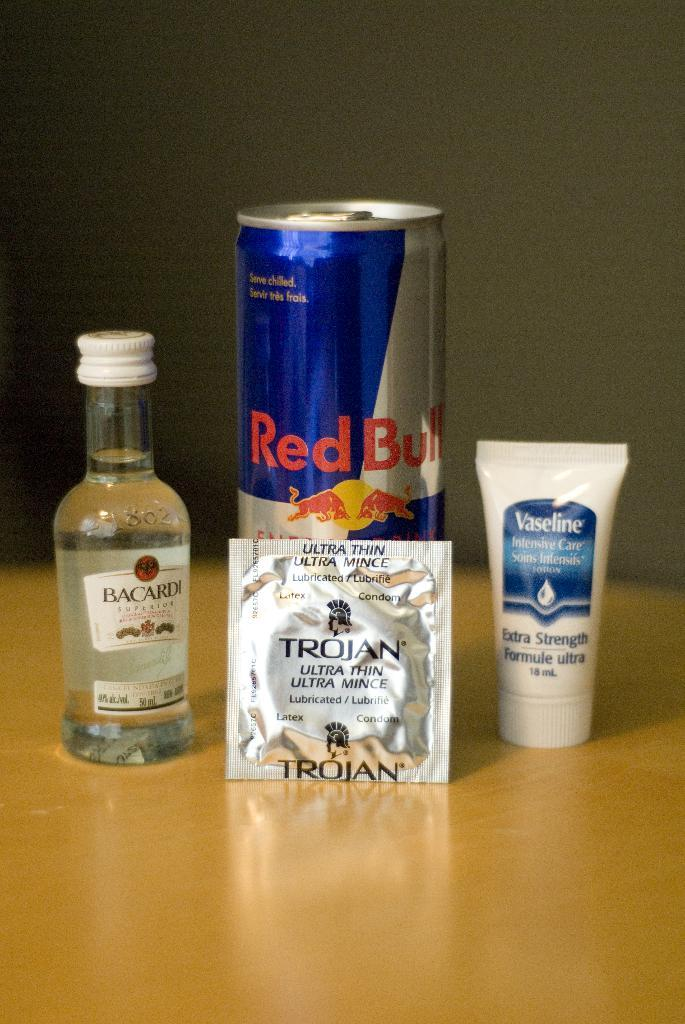Provide a one-sentence caption for the provided image. The can of red bull has a Trojan condom leaning on it, and is in between a travel sized bottle of Bacardi rum and a small tube of Vaseline. 